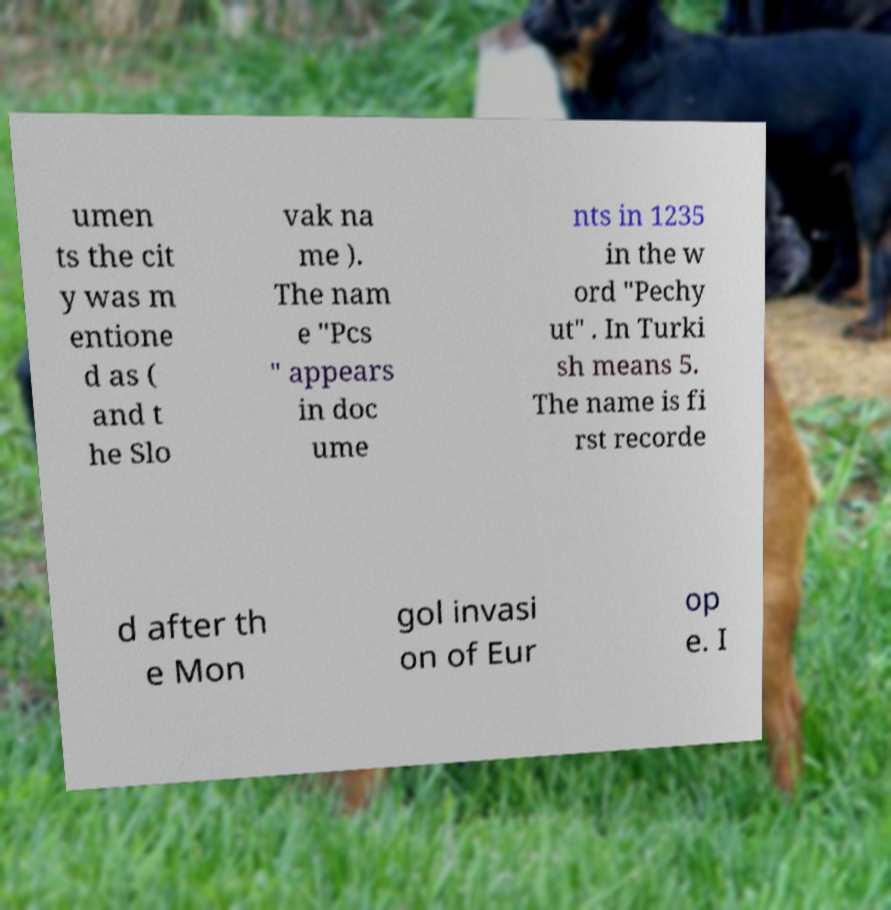Can you read and provide the text displayed in the image?This photo seems to have some interesting text. Can you extract and type it out for me? umen ts the cit y was m entione d as ( and t he Slo vak na me ). The nam e "Pcs " appears in doc ume nts in 1235 in the w ord "Pechy ut" . In Turki sh means 5. The name is fi rst recorde d after th e Mon gol invasi on of Eur op e. I 